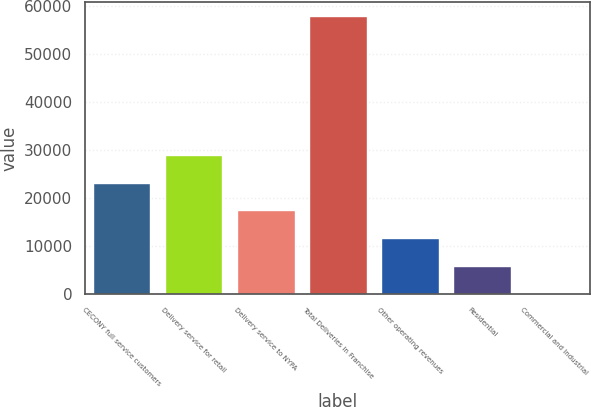<chart> <loc_0><loc_0><loc_500><loc_500><bar_chart><fcel>CECONY full service customers<fcel>Delivery service for retail<fcel>Delivery service to NYPA<fcel>Total Deliveries in Franchise<fcel>Other operating revenues<fcel>Residential<fcel>Commercial and Industrial<nl><fcel>23142.8<fcel>28923.3<fcel>17362.3<fcel>57826<fcel>11581.8<fcel>5801.23<fcel>20.7<nl></chart> 